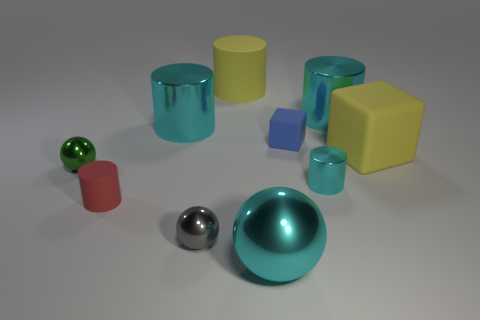Subtract all cyan cubes. How many cyan cylinders are left? 3 Subtract 1 cylinders. How many cylinders are left? 4 Subtract all yellow cylinders. How many cylinders are left? 4 Subtract all tiny red rubber cylinders. How many cylinders are left? 4 Subtract all green cylinders. Subtract all gray spheres. How many cylinders are left? 5 Subtract all balls. How many objects are left? 7 Add 8 large rubber objects. How many large rubber objects are left? 10 Add 4 cyan shiny things. How many cyan shiny things exist? 8 Subtract 1 yellow cylinders. How many objects are left? 9 Subtract all red matte objects. Subtract all green shiny things. How many objects are left? 8 